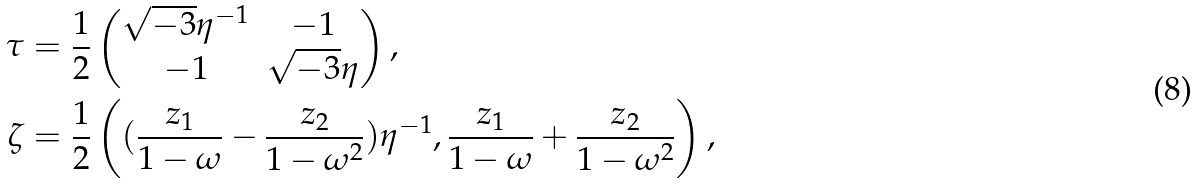<formula> <loc_0><loc_0><loc_500><loc_500>\tau & = \frac { 1 } { 2 } \begin{pmatrix} \sqrt { - 3 } \eta ^ { - 1 } & - 1 \\ - 1 & \sqrt { - 3 } \eta \\ \end{pmatrix} , \\ \zeta & = \frac { 1 } { 2 } \left ( ( \frac { z _ { 1 } } { 1 - \omega } - \frac { z _ { 2 } } { 1 - \omega ^ { 2 } } ) \eta ^ { - 1 } , \frac { z _ { 1 } } { 1 - \omega } + \frac { z _ { 2 } } { 1 - \omega ^ { 2 } } \right ) ,</formula> 